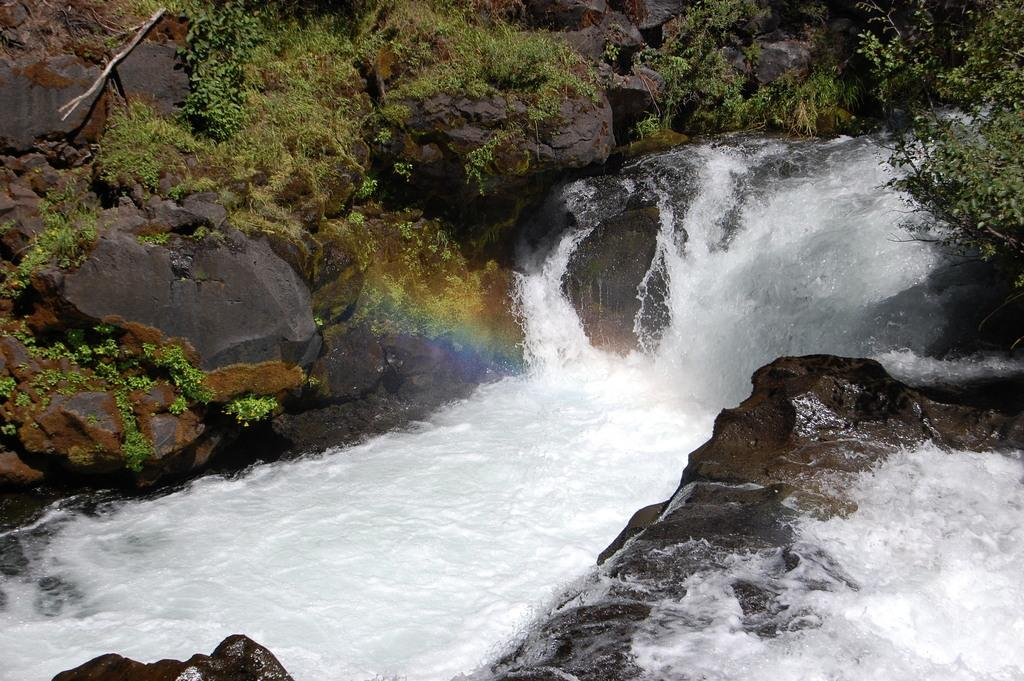What is the primary element visible in the image? There is water in the image. What other objects or features can be seen in the image? There are rocks in the image. What can be seen in the background of the image? There are plants and grass in the background of the image. Can you tell me how many donkeys are swimming in the ocean in the image? There is no ocean or donkeys present in the image. 